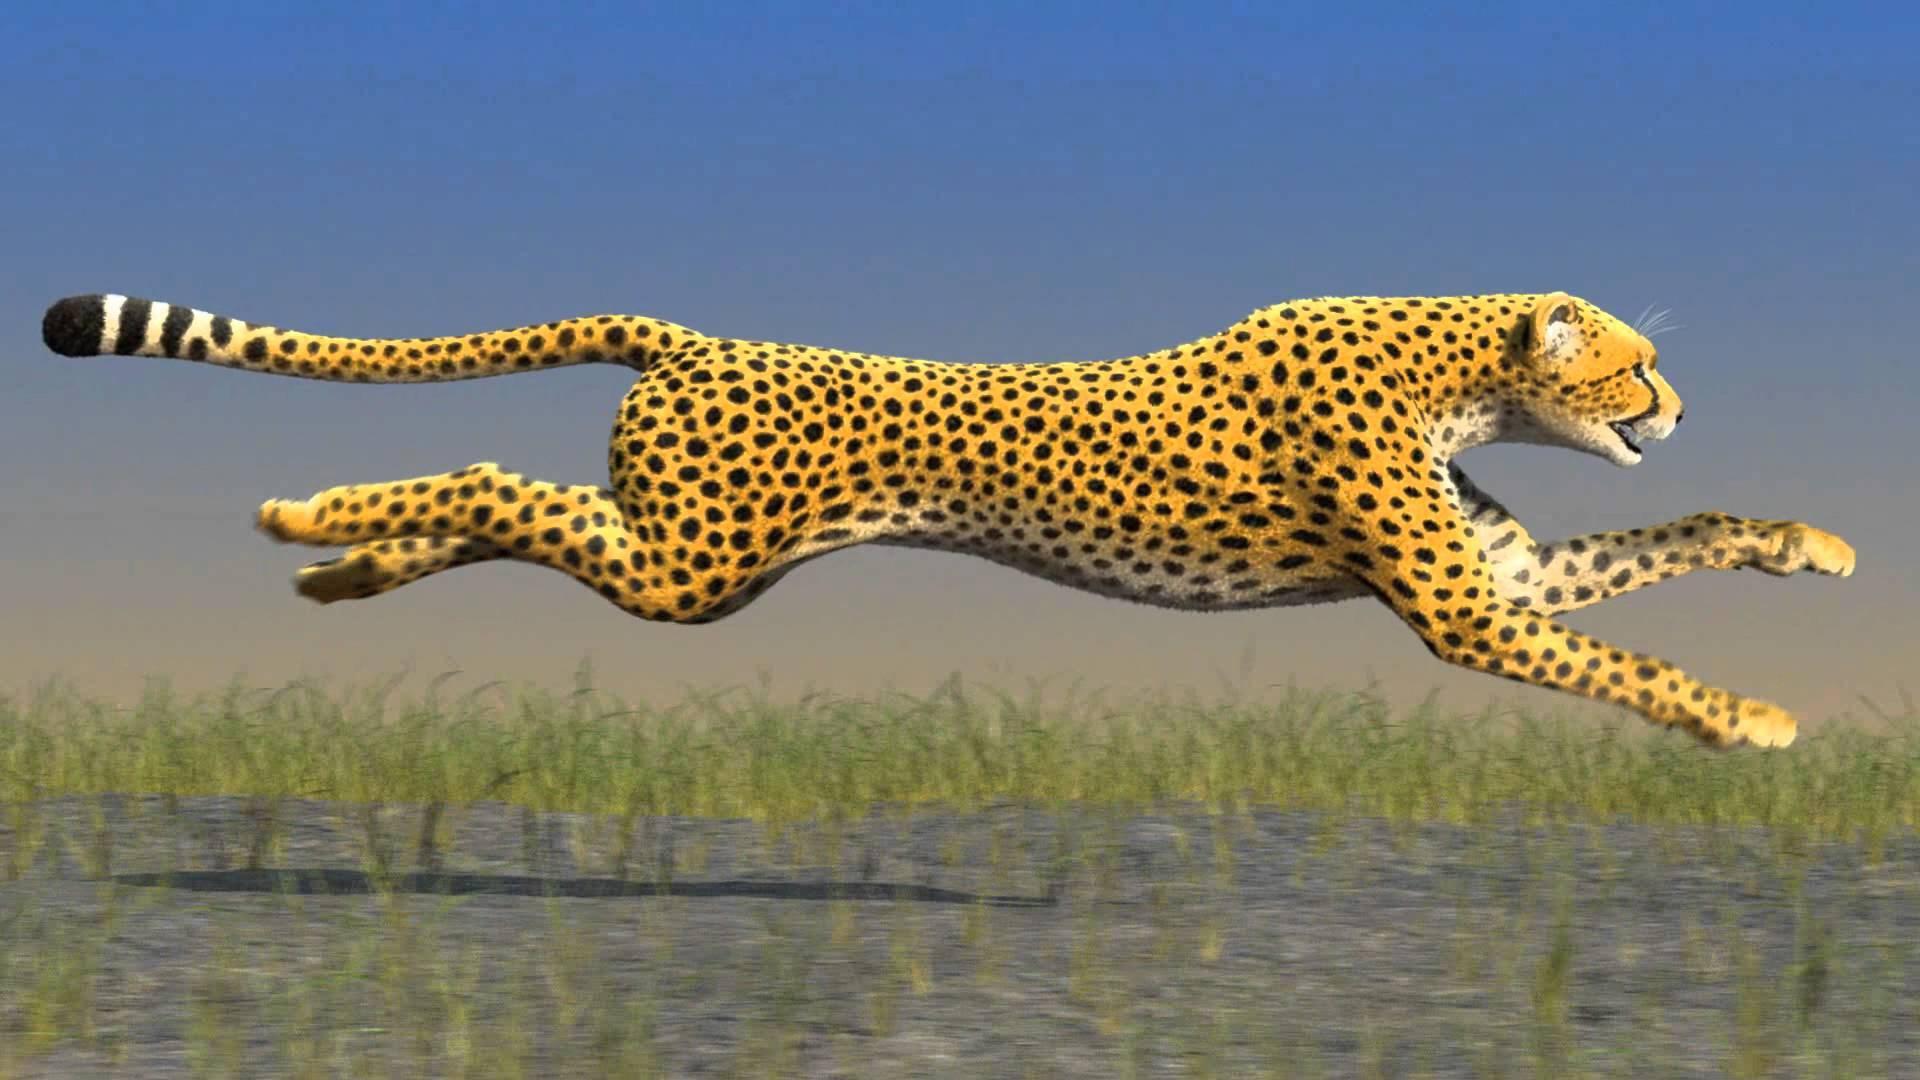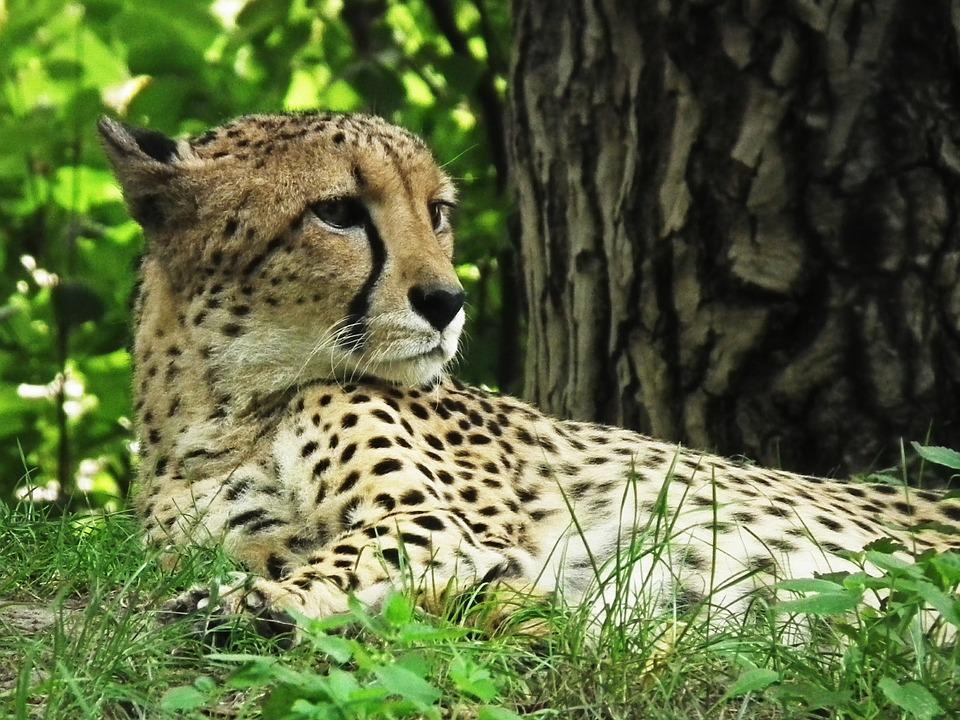The first image is the image on the left, the second image is the image on the right. Evaluate the accuracy of this statement regarding the images: "One image contains one cheetah, with its neck turned to gaze rightward, and the other image shows one cheetah in profile in a rightward bounding pose, with at least its front paws off the ground.". Is it true? Answer yes or no. Yes. The first image is the image on the left, the second image is the image on the right. Assess this claim about the two images: "One cheetah's front paws are off the ground.". Correct or not? Answer yes or no. Yes. 